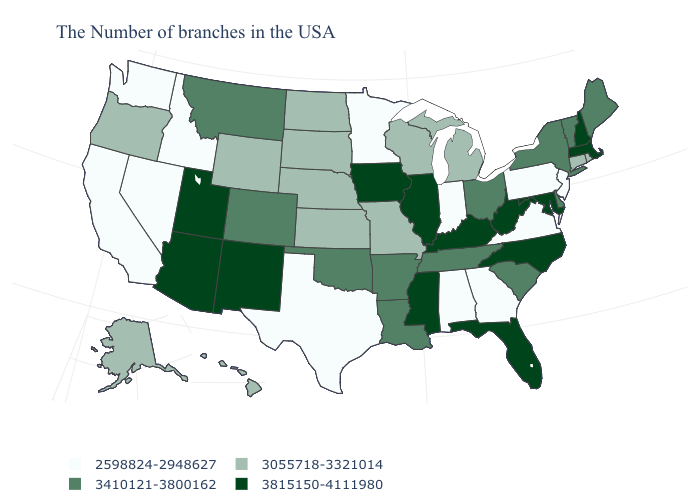Does the first symbol in the legend represent the smallest category?
Concise answer only. Yes. What is the value of Oklahoma?
Concise answer only. 3410121-3800162. What is the highest value in states that border Maine?
Short answer required. 3815150-4111980. Does South Dakota have a higher value than New York?
Give a very brief answer. No. Name the states that have a value in the range 3815150-4111980?
Concise answer only. Massachusetts, New Hampshire, Maryland, North Carolina, West Virginia, Florida, Kentucky, Illinois, Mississippi, Iowa, New Mexico, Utah, Arizona. Among the states that border New York , which have the highest value?
Give a very brief answer. Massachusetts. How many symbols are there in the legend?
Quick response, please. 4. Name the states that have a value in the range 3055718-3321014?
Answer briefly. Rhode Island, Connecticut, Michigan, Wisconsin, Missouri, Kansas, Nebraska, South Dakota, North Dakota, Wyoming, Oregon, Alaska, Hawaii. Which states hav the highest value in the MidWest?
Short answer required. Illinois, Iowa. Name the states that have a value in the range 3410121-3800162?
Be succinct. Maine, Vermont, New York, Delaware, South Carolina, Ohio, Tennessee, Louisiana, Arkansas, Oklahoma, Colorado, Montana. Does New Jersey have a higher value than Washington?
Write a very short answer. No. Among the states that border South Carolina , which have the lowest value?
Answer briefly. Georgia. Name the states that have a value in the range 3055718-3321014?
Write a very short answer. Rhode Island, Connecticut, Michigan, Wisconsin, Missouri, Kansas, Nebraska, South Dakota, North Dakota, Wyoming, Oregon, Alaska, Hawaii. What is the lowest value in the USA?
Answer briefly. 2598824-2948627. Name the states that have a value in the range 3815150-4111980?
Quick response, please. Massachusetts, New Hampshire, Maryland, North Carolina, West Virginia, Florida, Kentucky, Illinois, Mississippi, Iowa, New Mexico, Utah, Arizona. 